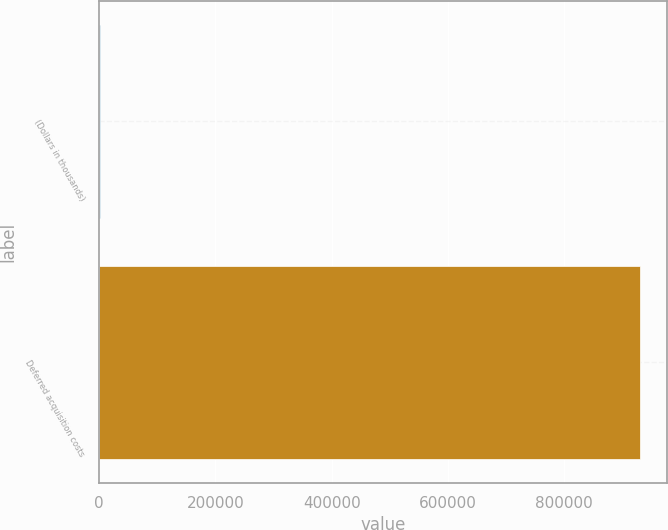Convert chart to OTSL. <chart><loc_0><loc_0><loc_500><loc_500><bar_chart><fcel>(Dollars in thousands)<fcel>Deferred acquisition costs<nl><fcel>2008<fcel>930694<nl></chart> 